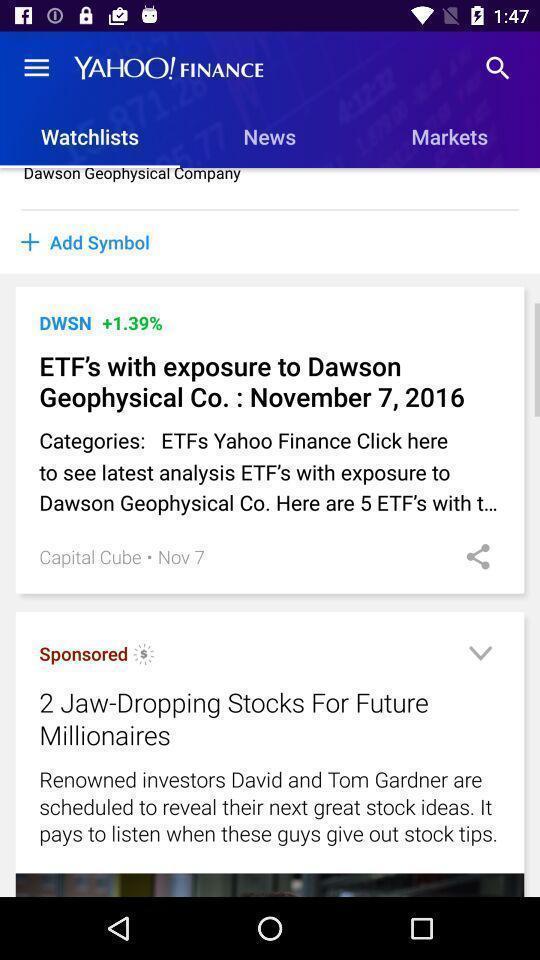Summarize the main components in this picture. Page displaying watchlists in app. 